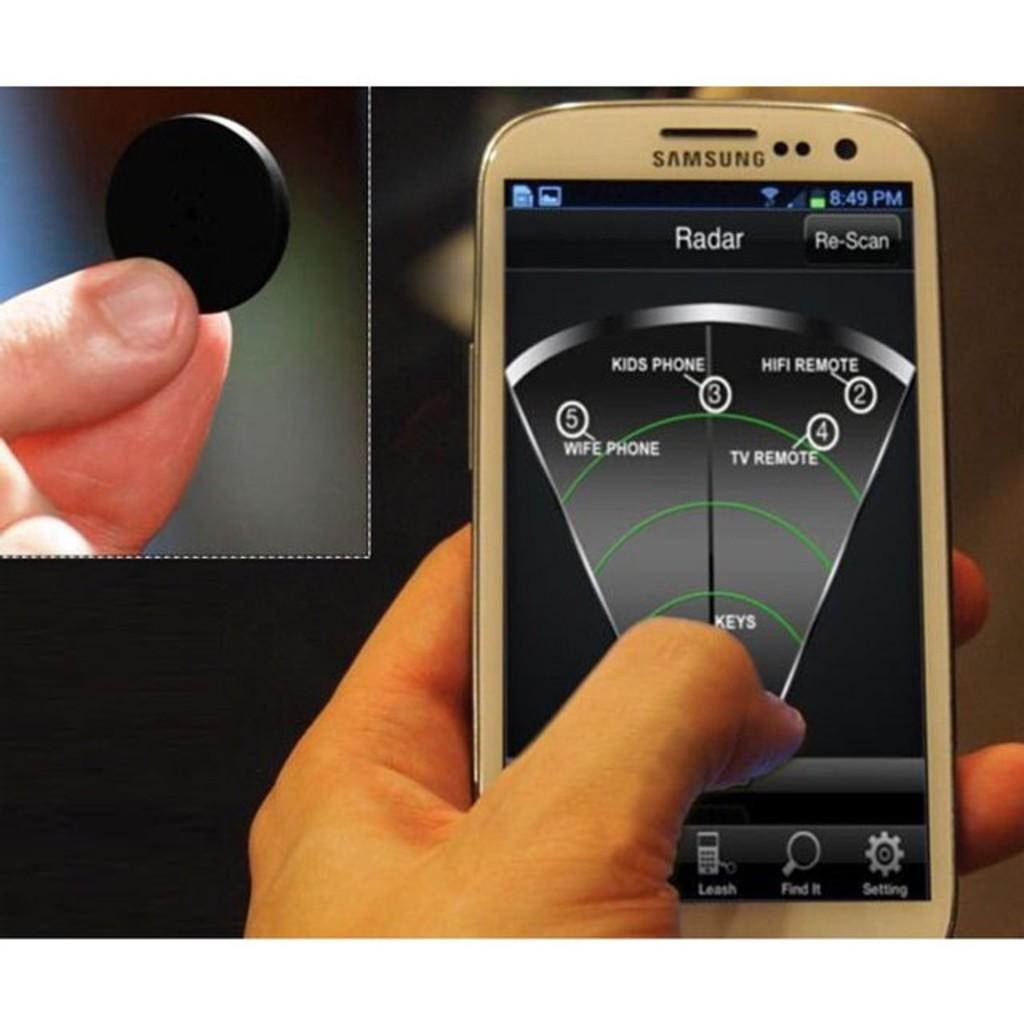<image>
Write a terse but informative summary of the picture. A white Samsung cellphone displaying a radar app. 